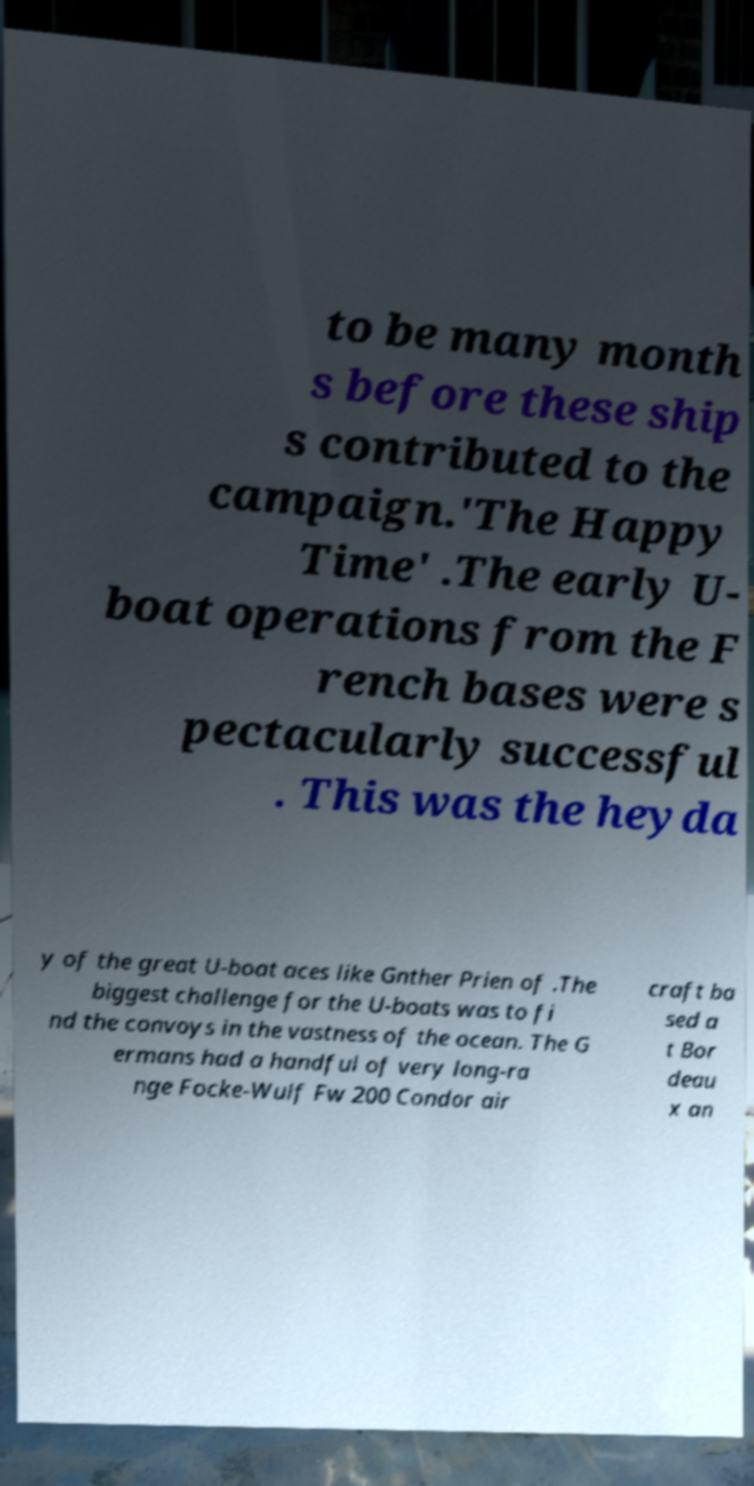Please identify and transcribe the text found in this image. to be many month s before these ship s contributed to the campaign.'The Happy Time' .The early U- boat operations from the F rench bases were s pectacularly successful . This was the heyda y of the great U-boat aces like Gnther Prien of .The biggest challenge for the U-boats was to fi nd the convoys in the vastness of the ocean. The G ermans had a handful of very long-ra nge Focke-Wulf Fw 200 Condor air craft ba sed a t Bor deau x an 